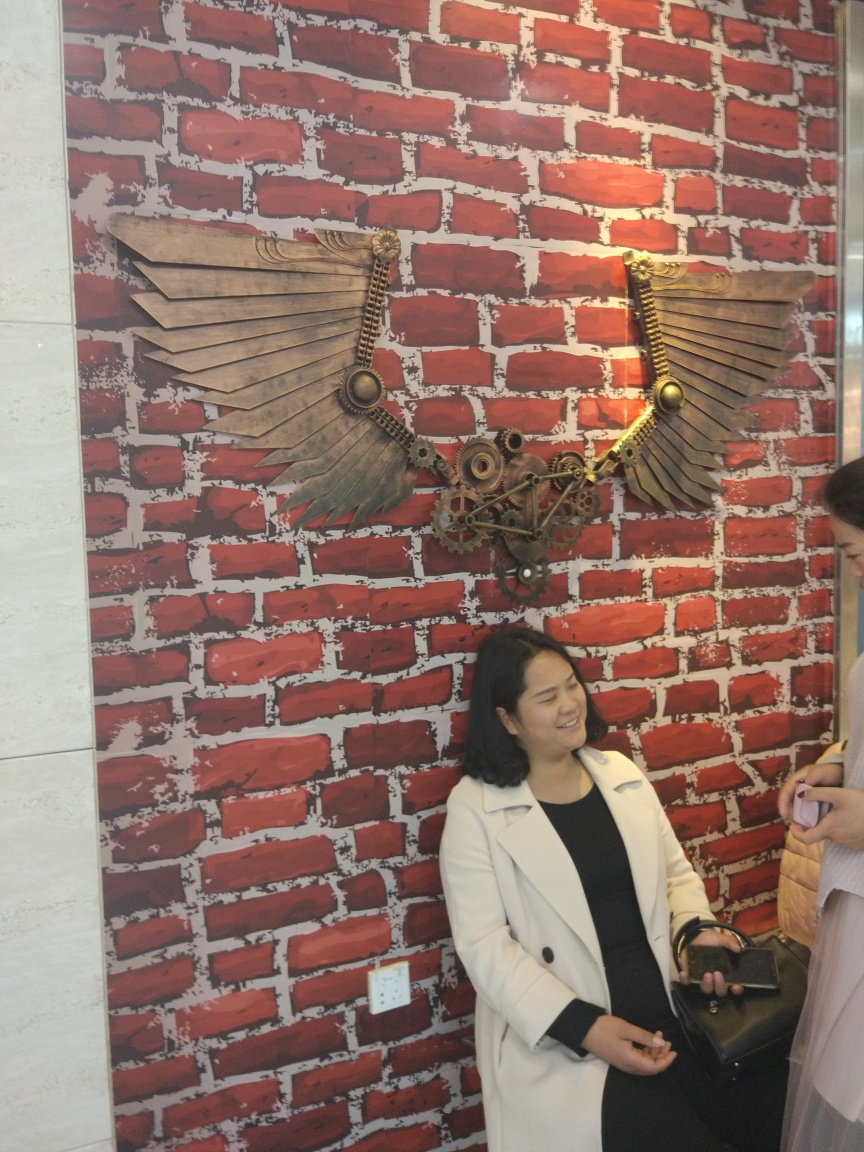What is the overall quality of the image? The overall quality of the image is quite good. The subjects are well-focused and the colors are vibrant. The creative mechanical wings on the brick wall background offer an interesting contrast that catches the eye. The lighting is balanced, with no harsh shadows obscuring the details, and the composition is engaging with the smile of the woman adding a pleasant human touch to the scene. 